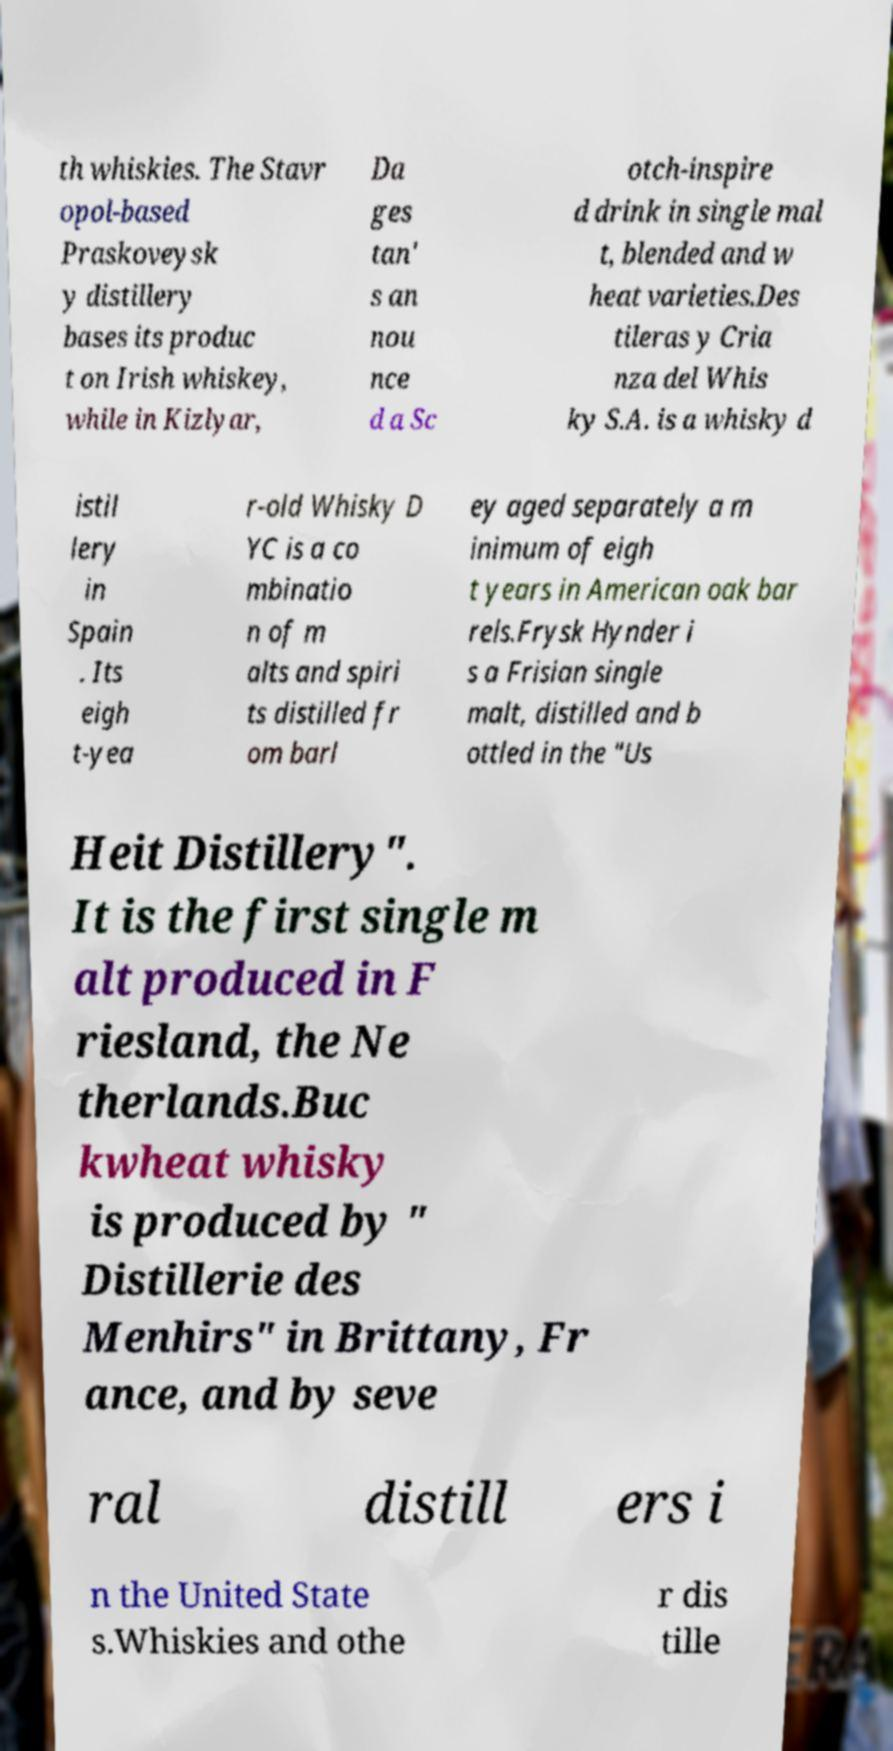For documentation purposes, I need the text within this image transcribed. Could you provide that? th whiskies. The Stavr opol-based Praskoveysk y distillery bases its produc t on Irish whiskey, while in Kizlyar, Da ges tan' s an nou nce d a Sc otch-inspire d drink in single mal t, blended and w heat varieties.Des tileras y Cria nza del Whis ky S.A. is a whisky d istil lery in Spain . Its eigh t-yea r-old Whisky D YC is a co mbinatio n of m alts and spiri ts distilled fr om barl ey aged separately a m inimum of eigh t years in American oak bar rels.Frysk Hynder i s a Frisian single malt, distilled and b ottled in the "Us Heit Distillery". It is the first single m alt produced in F riesland, the Ne therlands.Buc kwheat whisky is produced by " Distillerie des Menhirs" in Brittany, Fr ance, and by seve ral distill ers i n the United State s.Whiskies and othe r dis tille 